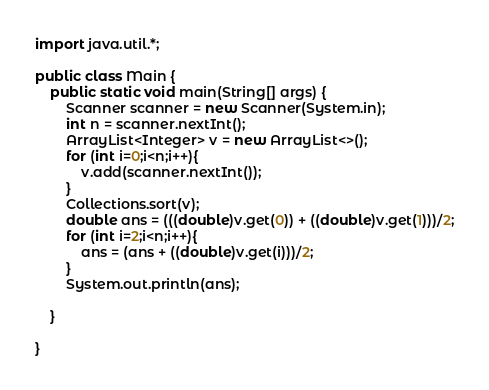Convert code to text. <code><loc_0><loc_0><loc_500><loc_500><_Java_>import java.util.*;

public class Main {
    public static void main(String[] args) {
        Scanner scanner = new Scanner(System.in);
        int n = scanner.nextInt();
        ArrayList<Integer> v = new ArrayList<>();
        for (int i=0;i<n;i++){
            v.add(scanner.nextInt());
        }
        Collections.sort(v);
        double ans = (((double)v.get(0)) + ((double)v.get(1)))/2;
        for (int i=2;i<n;i++){
            ans = (ans + ((double)v.get(i)))/2;
        }
        System.out.println(ans);

    }

}</code> 